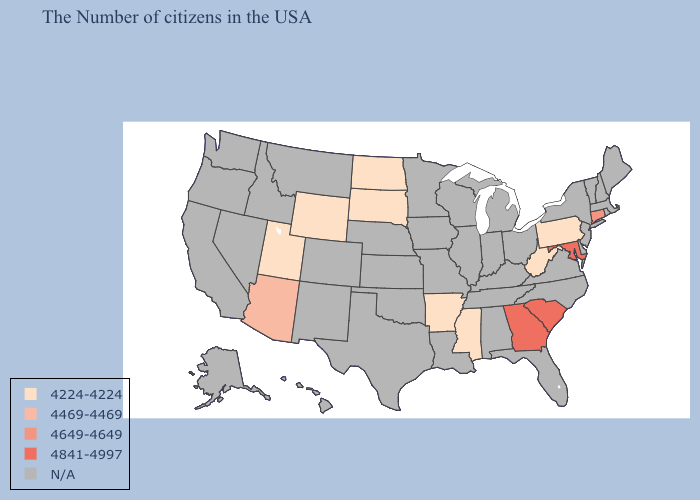Name the states that have a value in the range 4649-4649?
Give a very brief answer. Connecticut. What is the value of Alabama?
Concise answer only. N/A. Does the first symbol in the legend represent the smallest category?
Be succinct. Yes. What is the value of North Dakota?
Keep it brief. 4224-4224. What is the value of Arizona?
Quick response, please. 4469-4469. What is the highest value in the USA?
Quick response, please. 4841-4997. What is the value of Idaho?
Give a very brief answer. N/A. Does Arizona have the highest value in the USA?
Write a very short answer. No. Name the states that have a value in the range N/A?
Short answer required. Maine, Massachusetts, Rhode Island, New Hampshire, Vermont, New York, New Jersey, Delaware, Virginia, North Carolina, Ohio, Florida, Michigan, Kentucky, Indiana, Alabama, Tennessee, Wisconsin, Illinois, Louisiana, Missouri, Minnesota, Iowa, Kansas, Nebraska, Oklahoma, Texas, Colorado, New Mexico, Montana, Idaho, Nevada, California, Washington, Oregon, Alaska, Hawaii. What is the value of Georgia?
Keep it brief. 4841-4997. Among the states that border Wyoming , which have the highest value?
Concise answer only. South Dakota, Utah. What is the value of New Mexico?
Quick response, please. N/A. 